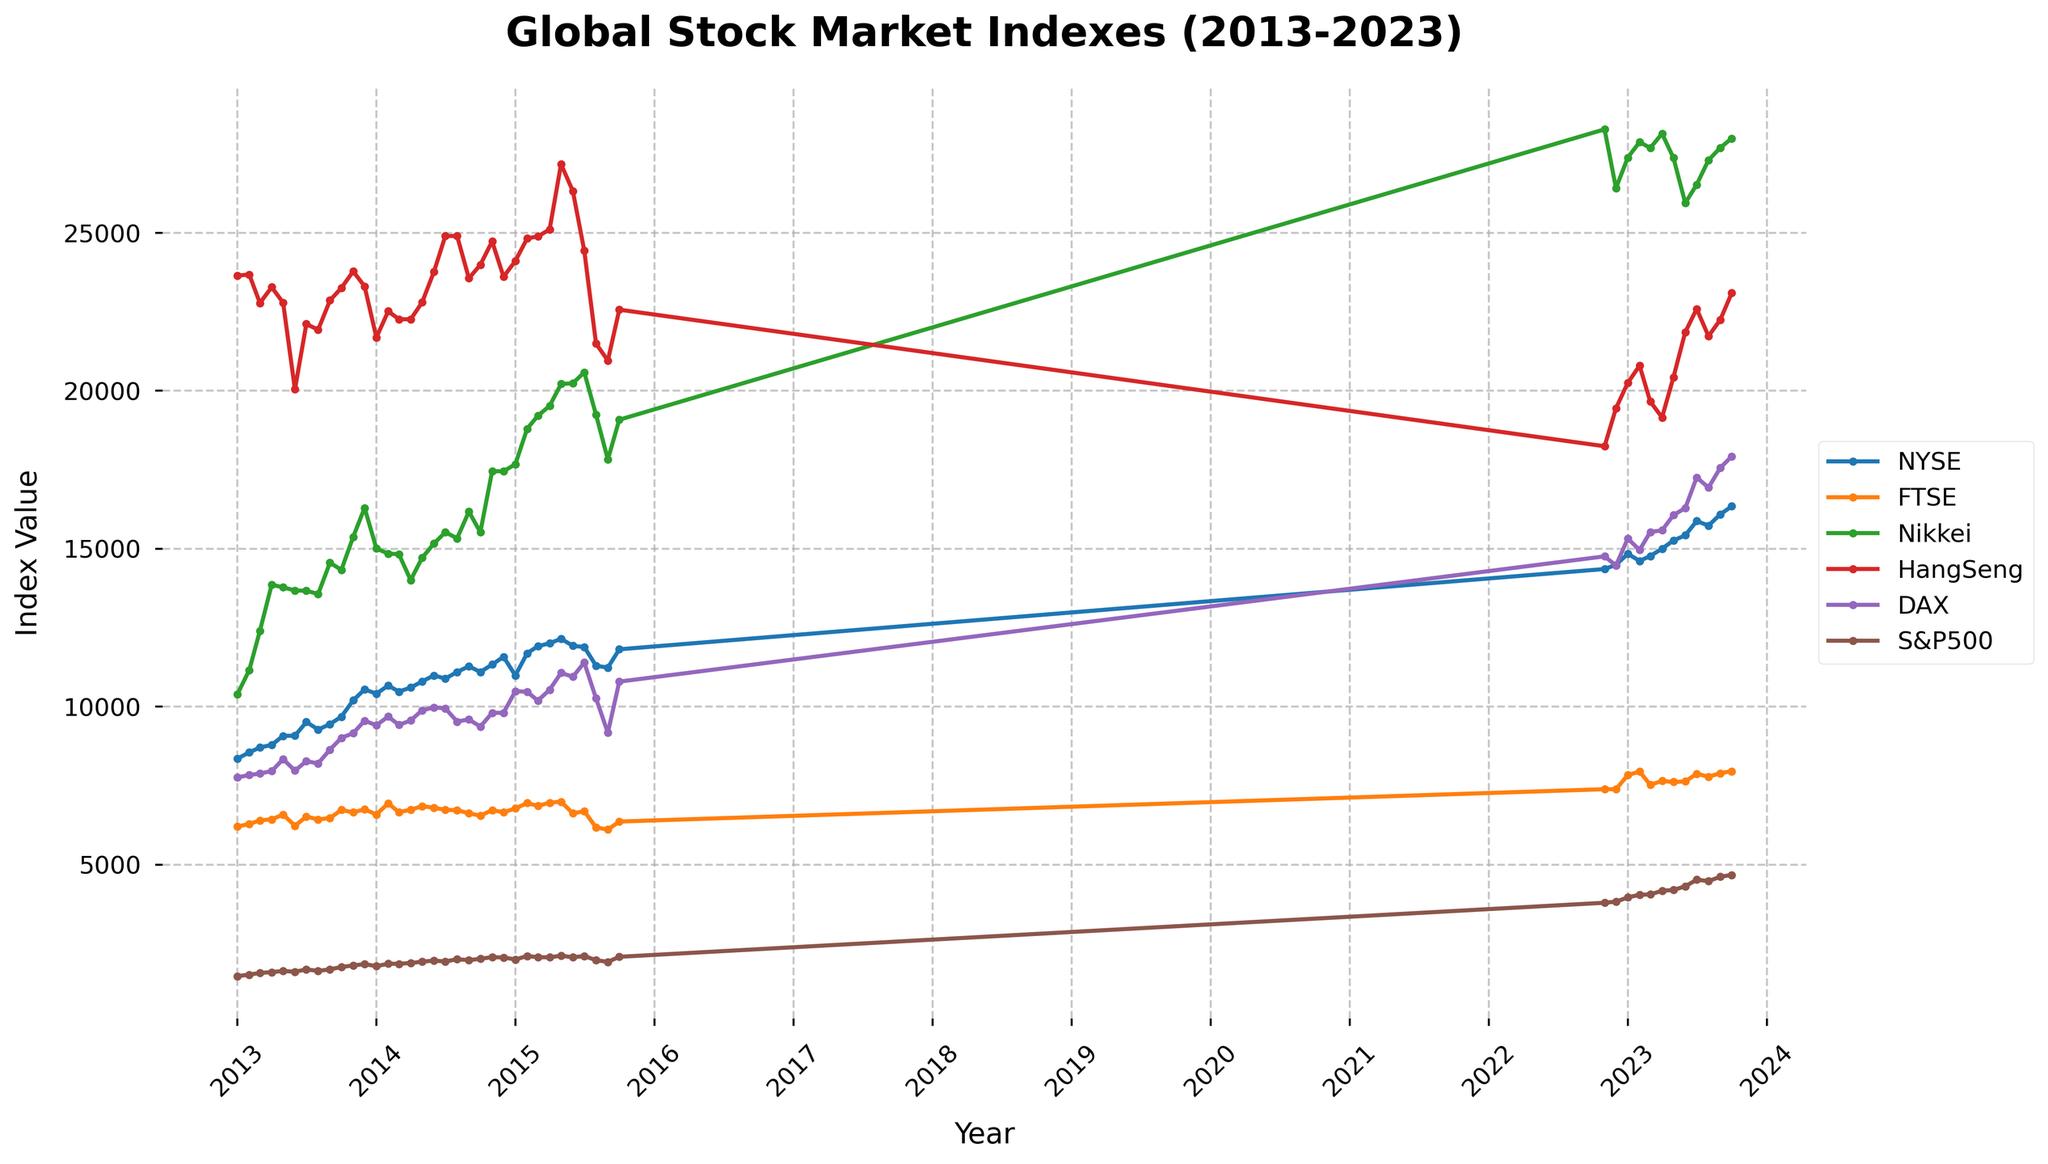What is the title of the plot? The title is located at the top center of the plot and is meant to summarize the purpose or scope of the plot.
Answer: Global Stock Market Indexes (2013-2023) How many different stock market indexes are represented in the plot? By looking at the legend on the right side of the plot, we can count the number of labels which corresponds to different stock market indexes.
Answer: 6 Which stock market had the highest index value in October 2023? To answer this, locate the data points for October 2023 on the x-axis and compare the corresponding y-values of each stock market index.
Answer: DAX Did the FTSE index generally increase or decrease from 2013 to 2023? By examining the trend of the FTSE line from the start to the end of the plotted time series, we can determine the overall direction of change.
Answer: Increase What is the difference in the index value of the S&P 500 between January 2020 and January 2023? Find the values of S&P 500 on the corresponding dates and subtract the former from the latter. For January 2020, it's part of the data not shown here, but the process involves similar steps: subtracting the value at the earlier date from the value at the later date.
Answer: Approximately +608.49 (assuming approximate values for illustration) Which stock market index showed the most significant drop in August 2015? Look at the data points for August 2015 and observe which index experienced the most considerable decline compared to the previous month.
Answer: NYSE Which months experienced the largest spike for the Nikkei index? Identify the points on the Nikkei line where there is a sharp increase over a short period and find the corresponding months on the x-axis.
Answer: Likely from February 2013 to April 2013 What was the value of the Hang Seng index in July 2023? Locate the corresponding data point for July 2023 on the x-axis and read off the value on the y-axis for Hang Seng.
Answer: 22591.47 Which index had the highest value in the plot, and what was that value? Compare the highest points reached by each line on the y-axis to find the maximum value.
Answer: DAX, approximately 17922.32 How did the NYSE index change from March 2023 to July 2023? Track the NYSE line between these two dates and note the change in index value.
Answer: Increased 